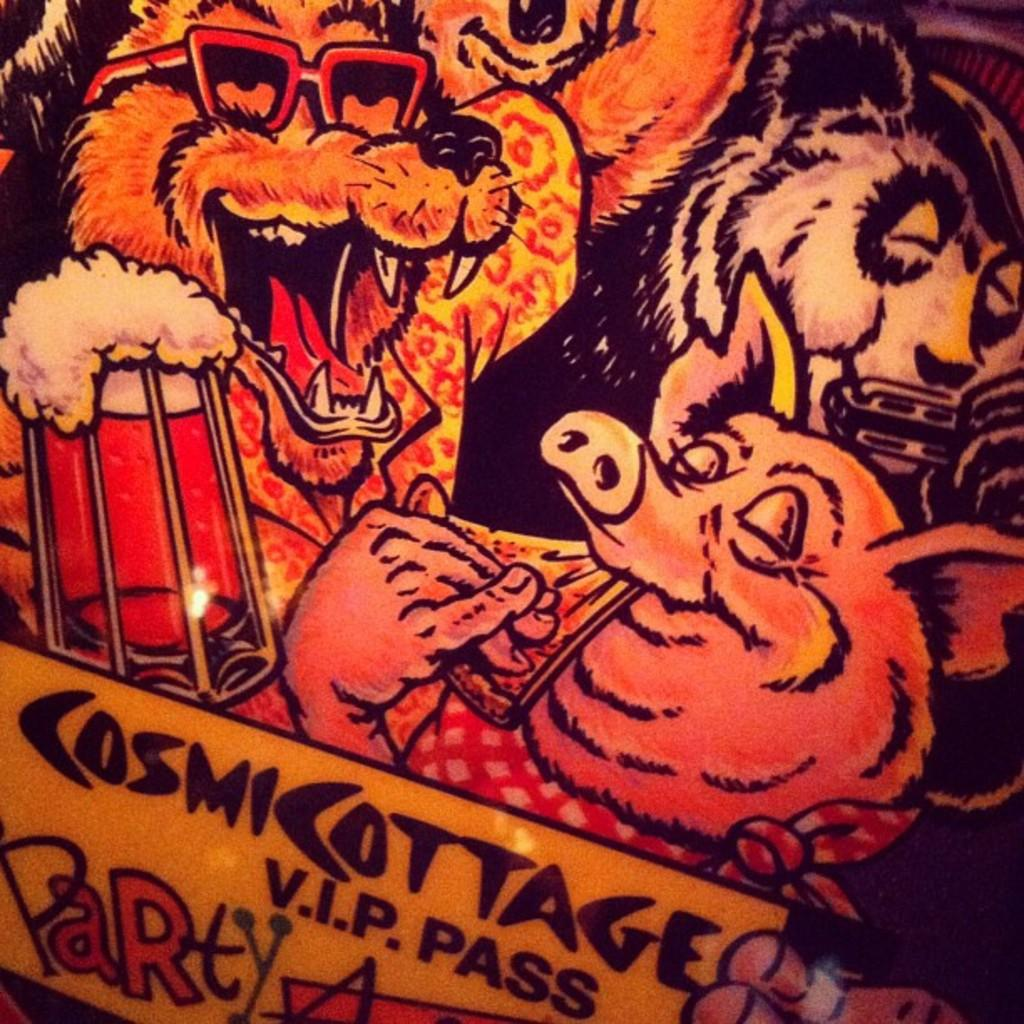What is present in the image that features multiple images? There is a poster in the image that contains images of many animals. What can be found at the bottom of the poster? There is text at the bottom of the poster. What type of appliance is being requested in the image? There is no appliance being requested in the image; it features a poster with images of animals and text. 